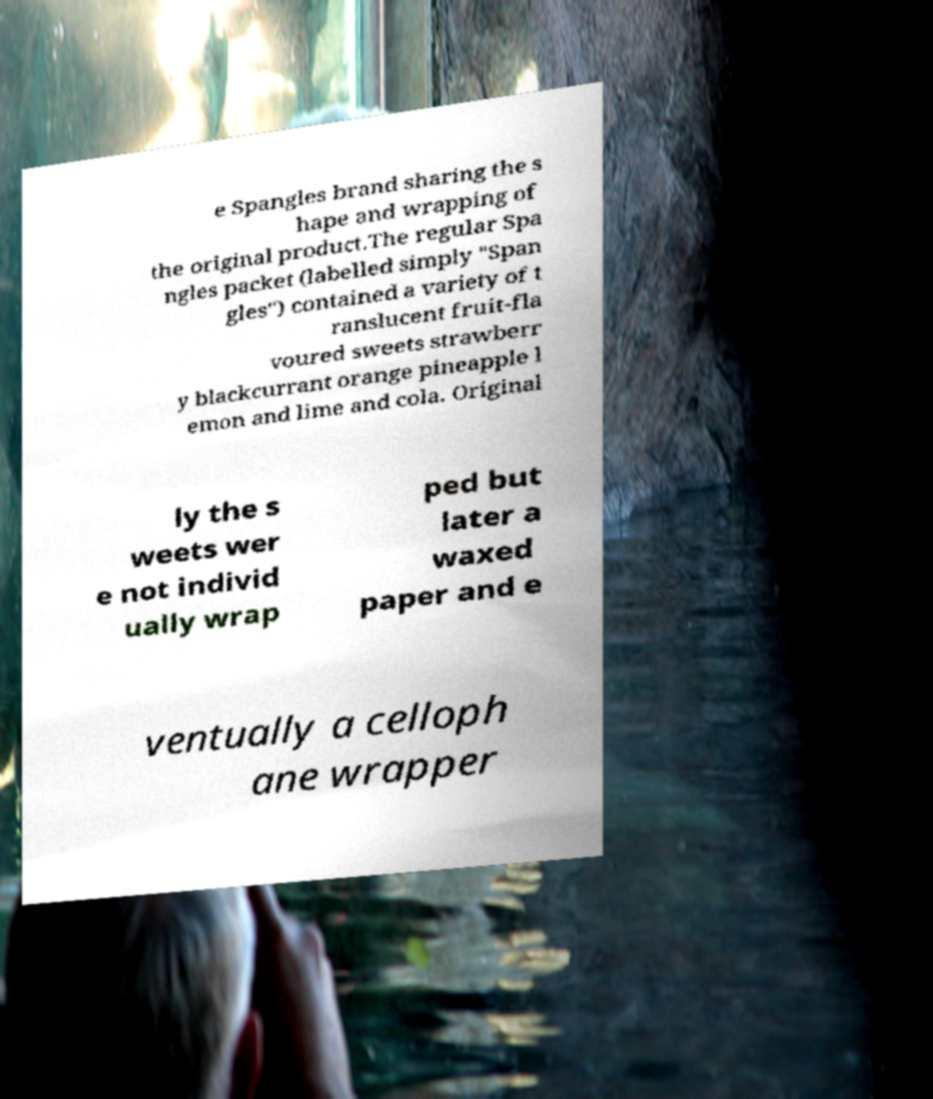For documentation purposes, I need the text within this image transcribed. Could you provide that? e Spangles brand sharing the s hape and wrapping of the original product.The regular Spa ngles packet (labelled simply "Span gles") contained a variety of t ranslucent fruit-fla voured sweets strawberr y blackcurrant orange pineapple l emon and lime and cola. Original ly the s weets wer e not individ ually wrap ped but later a waxed paper and e ventually a celloph ane wrapper 